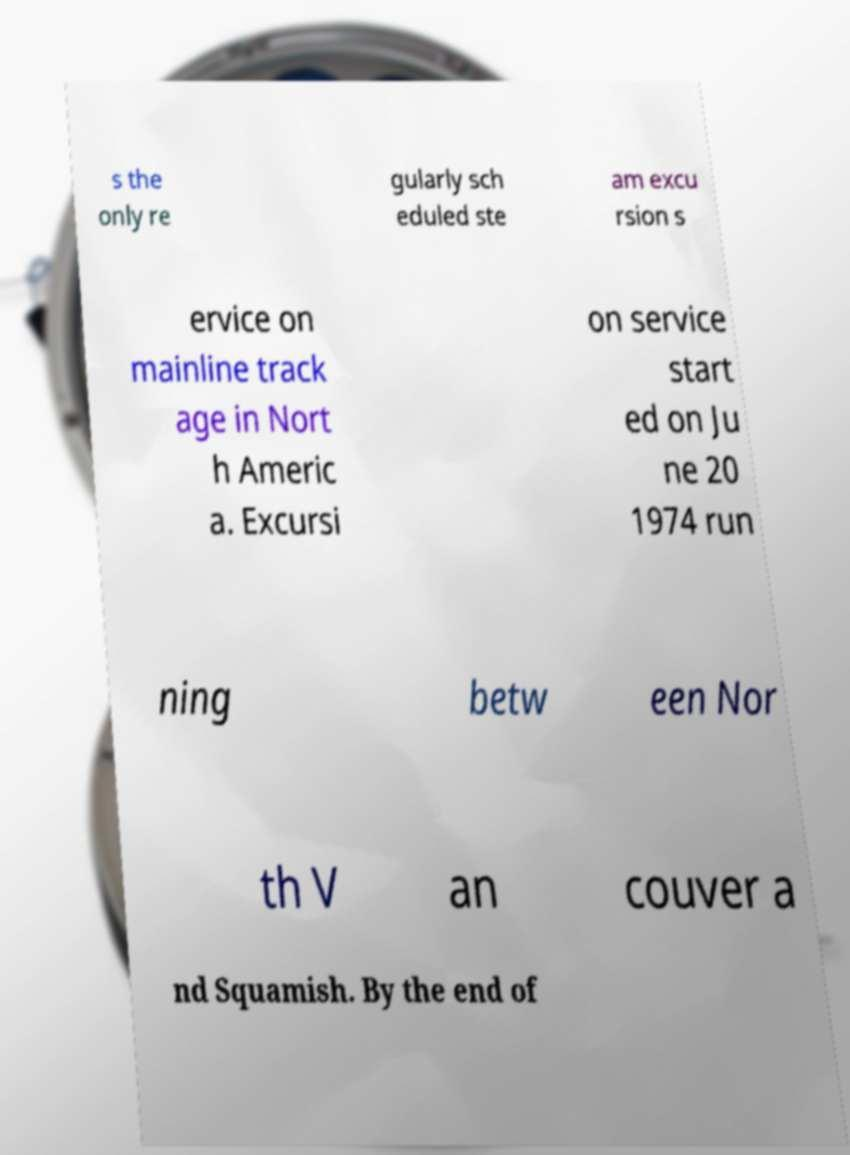Could you assist in decoding the text presented in this image and type it out clearly? s the only re gularly sch eduled ste am excu rsion s ervice on mainline track age in Nort h Americ a. Excursi on service start ed on Ju ne 20 1974 run ning betw een Nor th V an couver a nd Squamish. By the end of 